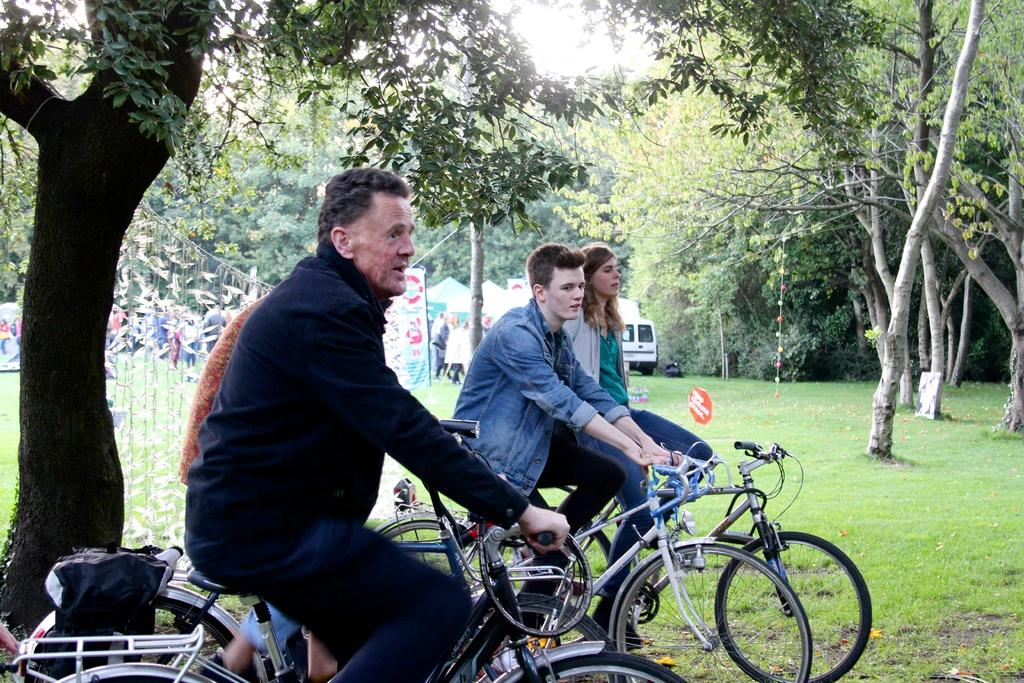What are the people in the image doing? The people in the image are on bicycles. What can be seen in the background of the image? There are trees and a vehicle in the background of the image. What is the land covered with in the image? The land is covered with grass. What is the position of the afterthought in the image? There is no afterthought present in the image. Can you describe how the people are pushing the bicycles in the image? The people are not pushing the bicycles; they are riding them. 